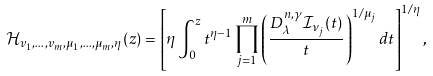Convert formula to latex. <formula><loc_0><loc_0><loc_500><loc_500>\mathcal { H } _ { v _ { 1 } , \dots , v _ { m } , \mu _ { 1 } , \dots , \mu _ { m } , \eta } ( z ) = \left [ \eta \int _ { 0 } ^ { z } t ^ { \eta - 1 } \prod _ { j = 1 } ^ { m } \left ( \frac { D _ { \lambda } ^ { n , \gamma } \mathcal { I } _ { \nu _ { j } } ( t ) } { t } \right ) ^ { 1 / \mu _ { j } } d t \right ] ^ { 1 / \eta } ,</formula> 